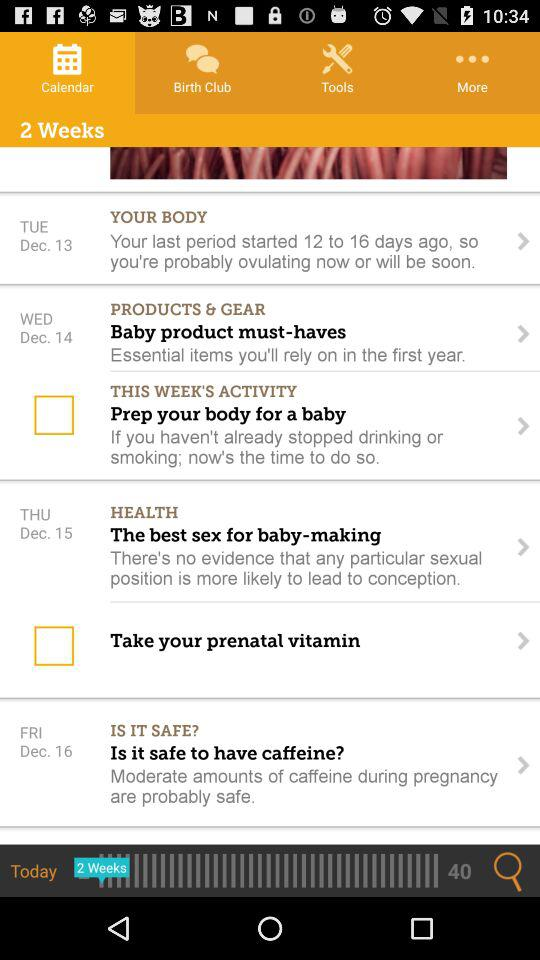What's the date for "YOUR BODY"? The date is Tuesday, December 13. 